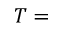Convert formula to latex. <formula><loc_0><loc_0><loc_500><loc_500>T =</formula> 